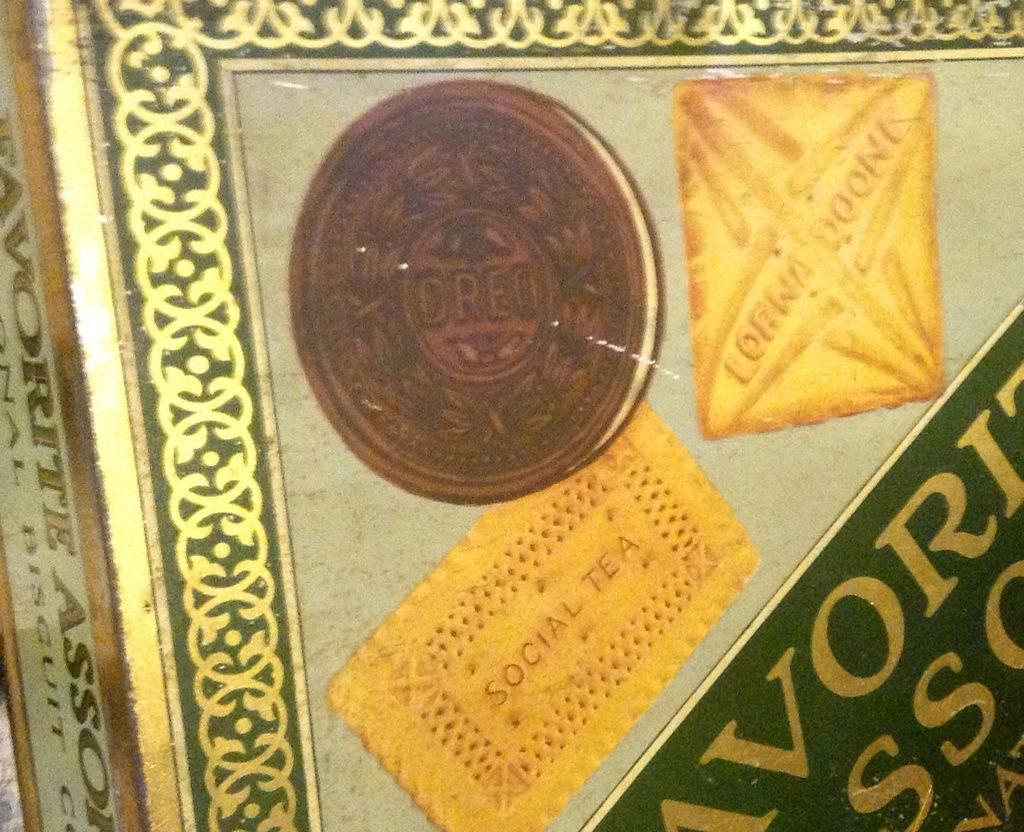What object is present in the picture? There is a box in the picture. What can be seen on the box? There is information visible on the box. What type of product might the box contain? The depictions of biscuits on the box suggest that it contains biscuits. How many stitches are visible on the biscuits in the image? There are no stitches visible on the biscuits in the image, as biscuits do not have stitches. 